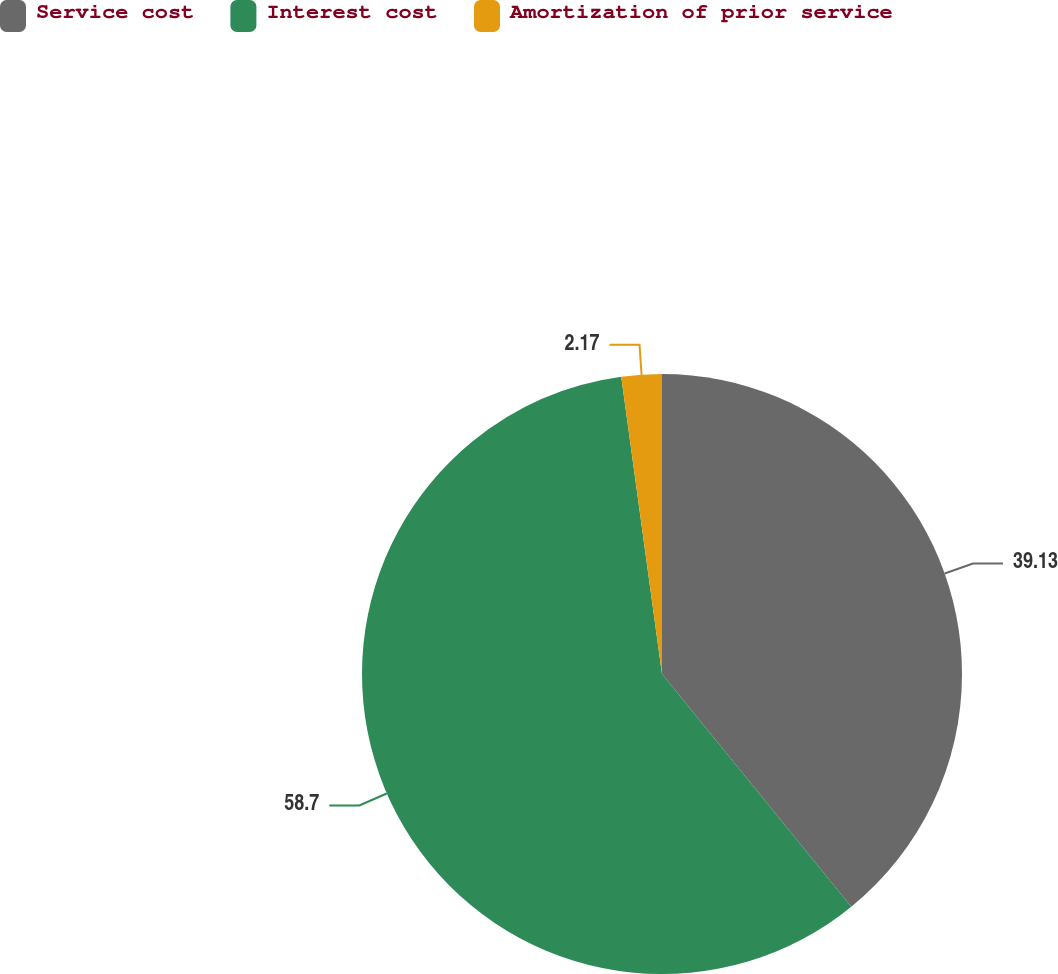Convert chart to OTSL. <chart><loc_0><loc_0><loc_500><loc_500><pie_chart><fcel>Service cost<fcel>Interest cost<fcel>Amortization of prior service<nl><fcel>39.13%<fcel>58.7%<fcel>2.17%<nl></chart> 